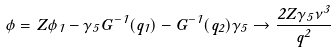<formula> <loc_0><loc_0><loc_500><loc_500>\phi = Z \phi _ { 1 } - \gamma _ { 5 } G ^ { - 1 } ( q _ { 1 } ) - G ^ { - 1 } ( q _ { 2 } ) \gamma _ { 5 } \rightarrow \frac { 2 Z \gamma _ { 5 } \nu ^ { 3 } } { q ^ { 2 } }</formula> 